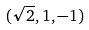Convert formula to latex. <formula><loc_0><loc_0><loc_500><loc_500>( \sqrt { 2 } , 1 , - 1 )</formula> 